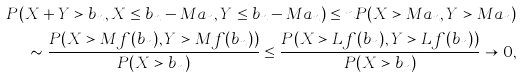<formula> <loc_0><loc_0><loc_500><loc_500>P ( X + Y > b _ { n } , X \leq b _ { n } - M a _ { n } , Y \leq b _ { n } - M a _ { n } ) \leq n P ( X > M a _ { n } , Y > M a _ { n } ) \\ \sim \frac { P ( X > M f ( b _ { n } ) , Y > M f ( b _ { n } ) ) } { P ( X > b _ { n } ) } \leq \frac { P ( X > L f ( b _ { n } ) , Y > L f ( b _ { n } ) ) } { P ( X > b _ { n } ) } \rightarrow 0 ,</formula> 